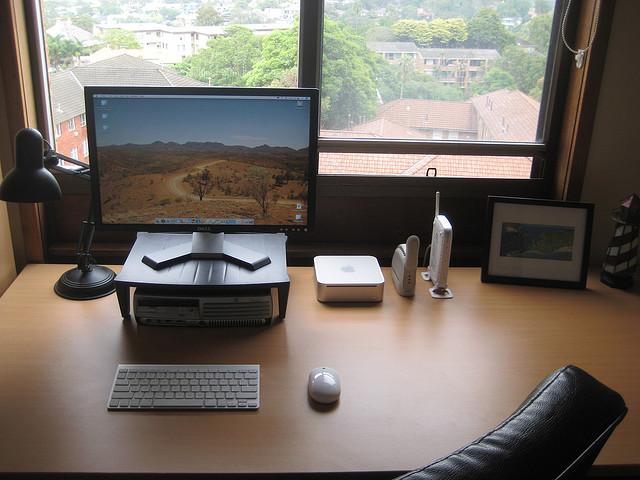Is the desk lamp on?
Quick response, please. No. Is the owner of this office using a Mac or a PC?
Concise answer only. Pc. Where is the keyboard?
Be succinct. Desk. 